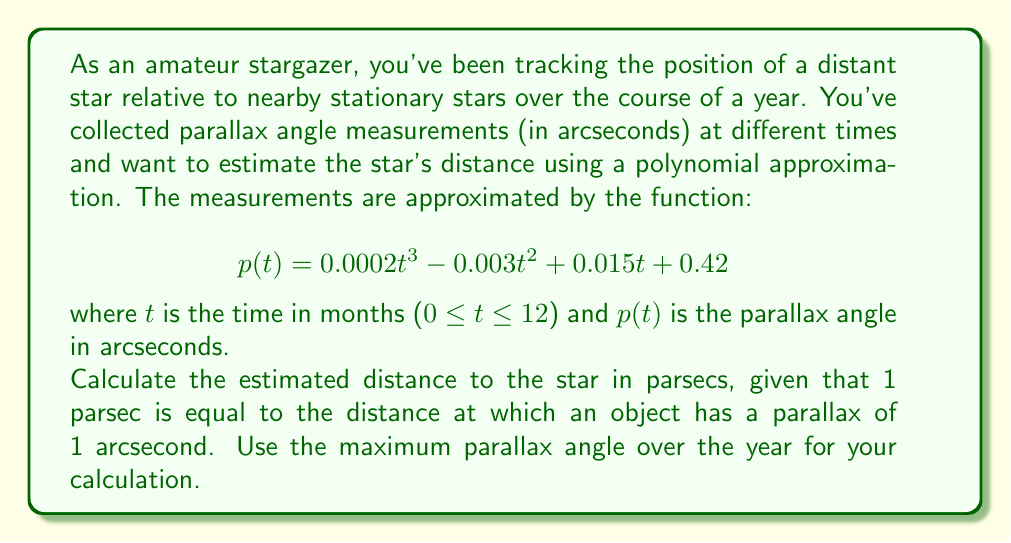Can you answer this question? To solve this problem, we need to follow these steps:

1. Find the maximum parallax angle over the year.
2. Use the relationship between parsecs and parallax angles to calculate the distance.

Step 1: Finding the maximum parallax angle

The parallax angle is given by the polynomial function:

$$p(t) = 0.0002t^3 - 0.003t^2 + 0.015t + 0.42$$

To find the maximum value, we need to find the critical points by taking the derivative and setting it to zero:

$$p'(t) = 0.0006t^2 - 0.006t + 0.015$$

Setting $p'(t) = 0$:

$$0.0006t^2 - 0.006t + 0.015 = 0$$

This is a quadratic equation. We can solve it using the quadratic formula:

$$t = \frac{-b \pm \sqrt{b^2 - 4ac}}{2a}$$

Where $a = 0.0006$, $b = -0.006$, and $c = 0.015$

Solving this gives us two critical points: $t ≈ 3.43$ and $t ≈ 6.57$

We also need to check the endpoints of our interval (0 and 12).

Evaluating $p(t)$ at these points:

$p(0) = 0.42$
$p(3.43) ≈ 0.4456$
$p(6.57) ≈ 0.4456$
$p(12) ≈ 0.42$

The maximum parallax angle occurs at $t ≈ 3.43$ and $t ≈ 6.57$, with a value of approximately 0.4456 arcseconds.

Step 2: Calculating the distance

The relationship between distance in parsecs and parallax angle in arcseconds is:

$$\text{Distance (parsecs)} = \frac{1}{\text{Parallax (arcseconds)}}$$

Using our maximum parallax angle:

$$\text{Distance} = \frac{1}{0.4456} ≈ 2.2442 \text{ parsecs}$$
Answer: The estimated distance to the star is approximately 2.24 parsecs. 